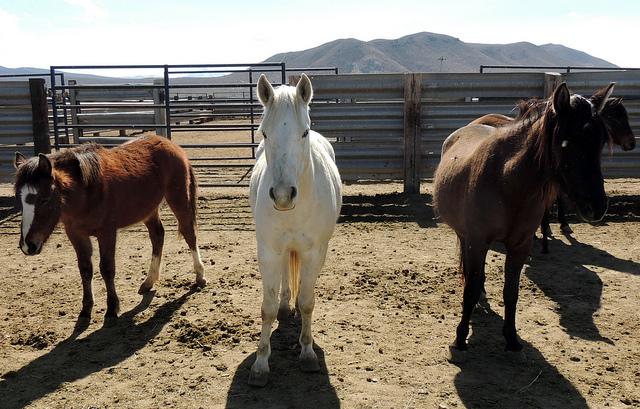Are these horses wild?
Write a very short answer. No. What is behind the horses?
Be succinct. Fence. What is the name of the marking that appears on the horse on the left's face?
Quick response, please. Brand. What type of man-made item is visible behind the horses?
Be succinct. Fence. 